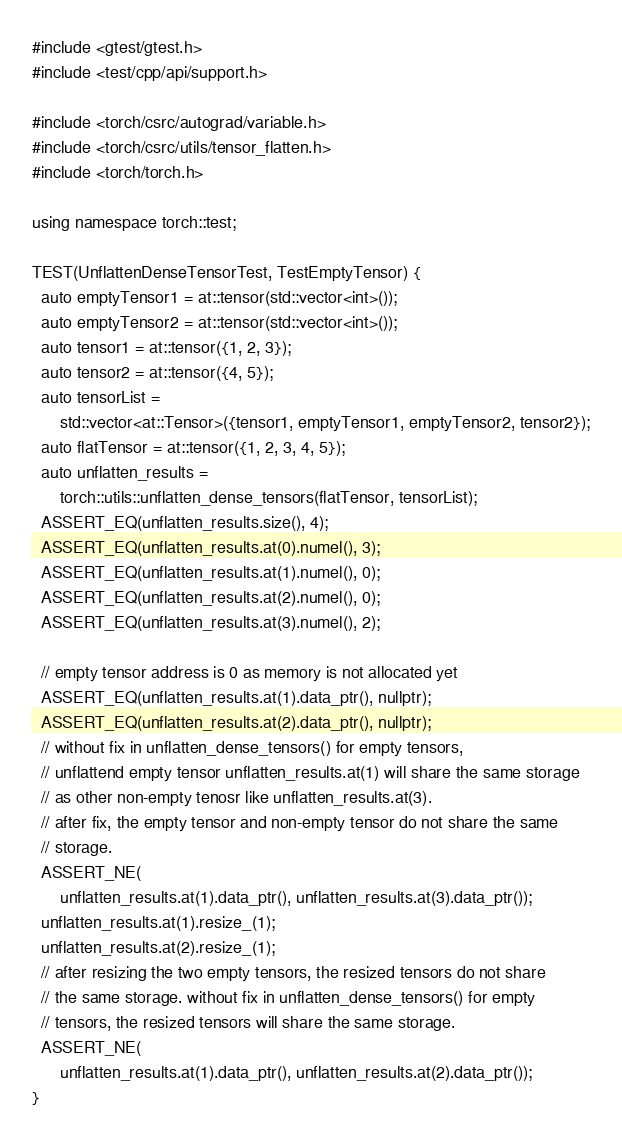Convert code to text. <code><loc_0><loc_0><loc_500><loc_500><_C++_>#include <gtest/gtest.h>
#include <test/cpp/api/support.h>

#include <torch/csrc/autograd/variable.h>
#include <torch/csrc/utils/tensor_flatten.h>
#include <torch/torch.h>

using namespace torch::test;

TEST(UnflattenDenseTensorTest, TestEmptyTensor) {
  auto emptyTensor1 = at::tensor(std::vector<int>());
  auto emptyTensor2 = at::tensor(std::vector<int>());
  auto tensor1 = at::tensor({1, 2, 3});
  auto tensor2 = at::tensor({4, 5});
  auto tensorList =
      std::vector<at::Tensor>({tensor1, emptyTensor1, emptyTensor2, tensor2});
  auto flatTensor = at::tensor({1, 2, 3, 4, 5});
  auto unflatten_results =
      torch::utils::unflatten_dense_tensors(flatTensor, tensorList);
  ASSERT_EQ(unflatten_results.size(), 4);
  ASSERT_EQ(unflatten_results.at(0).numel(), 3);
  ASSERT_EQ(unflatten_results.at(1).numel(), 0);
  ASSERT_EQ(unflatten_results.at(2).numel(), 0);
  ASSERT_EQ(unflatten_results.at(3).numel(), 2);

  // empty tensor address is 0 as memory is not allocated yet
  ASSERT_EQ(unflatten_results.at(1).data_ptr(), nullptr);
  ASSERT_EQ(unflatten_results.at(2).data_ptr(), nullptr);
  // without fix in unflatten_dense_tensors() for empty tensors,
  // unflattend empty tensor unflatten_results.at(1) will share the same storage
  // as other non-empty tenosr like unflatten_results.at(3).
  // after fix, the empty tensor and non-empty tensor do not share the same
  // storage.
  ASSERT_NE(
      unflatten_results.at(1).data_ptr(), unflatten_results.at(3).data_ptr());
  unflatten_results.at(1).resize_(1);
  unflatten_results.at(2).resize_(1);
  // after resizing the two empty tensors, the resized tensors do not share
  // the same storage. without fix in unflatten_dense_tensors() for empty
  // tensors, the resized tensors will share the same storage.
  ASSERT_NE(
      unflatten_results.at(1).data_ptr(), unflatten_results.at(2).data_ptr());
}
</code> 